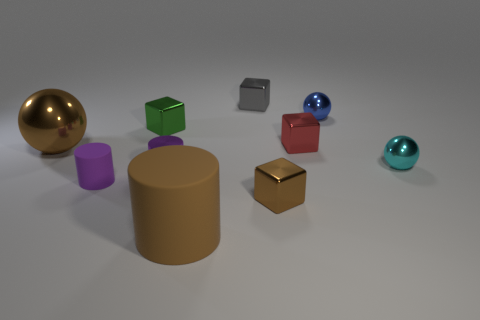Subtract all green cubes. How many cubes are left? 3 Subtract all tiny red shiny blocks. How many blocks are left? 3 Subtract all yellow cubes. Subtract all brown balls. How many cubes are left? 4 Subtract all cubes. How many objects are left? 6 Add 2 large objects. How many large objects exist? 4 Subtract 0 cyan cylinders. How many objects are left? 10 Subtract all small shiny cylinders. Subtract all small cyan shiny things. How many objects are left? 8 Add 3 cyan metal balls. How many cyan metal balls are left? 4 